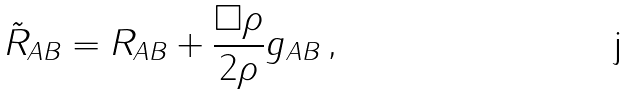<formula> <loc_0><loc_0><loc_500><loc_500>\tilde { R } _ { A B } = R _ { A B } + \frac { \Box \rho } { 2 \rho } g _ { A B } \, ,</formula> 